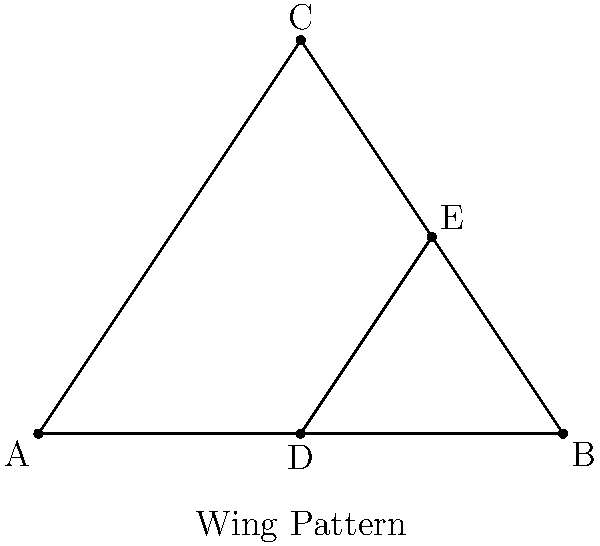In studying the symmetry of butterfly wing patterns, you observe a triangular section of a wing represented by triangle ABC. If point D is the midpoint of AB and point E is on BC such that DE is parallel to AC, which of the following statements about congruence is true? Let's approach this step-by-step:

1) First, we know that D is the midpoint of AB. This means AD = DB.

2) DE is parallel to AC. This creates similar triangles ADE and ABC.

3) In similar triangles, corresponding sides are proportional. Since D is the midpoint of AB, DE must be half the length of AC.

4) This means that E must be the midpoint of BC.

5) Now, let's consider triangles ADE and BEC:
   - AD = DB (D is midpoint of AB)
   - DE is common to both triangles
   - AE = EC (E is midpoint of BC, as we proved)

6) By the Side-Side-Side (SSS) congruence criterion, if three sides of one triangle are equal to three sides of another triangle, the triangles are congruent.

7) Therefore, triangle ADE is congruent to triangle BEC.

This congruence demonstrates a form of symmetry in the butterfly wing pattern, where the wing is divided into congruent sections.
Answer: Triangle ADE is congruent to triangle BEC. 